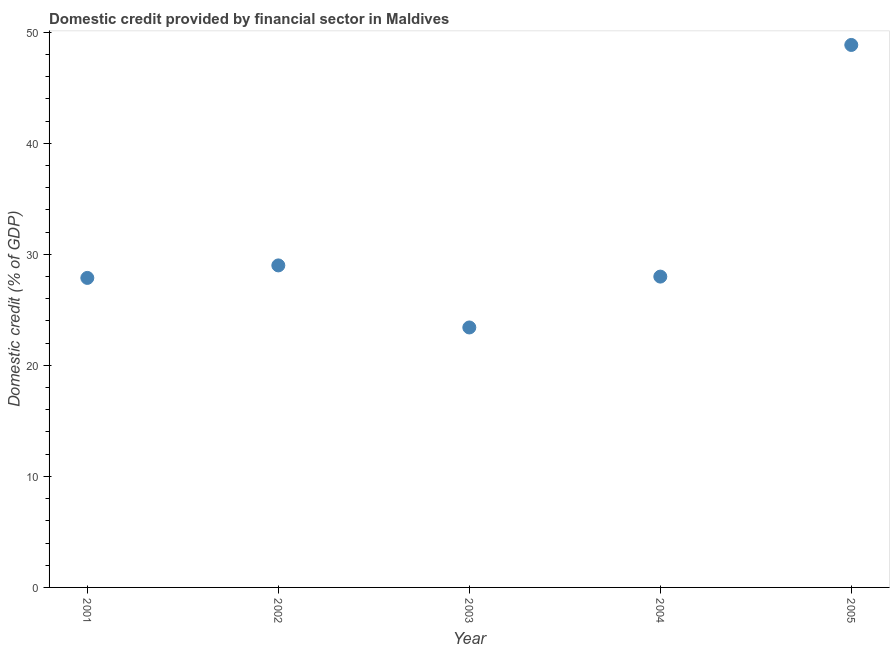What is the domestic credit provided by financial sector in 2005?
Provide a succinct answer. 48.85. Across all years, what is the maximum domestic credit provided by financial sector?
Provide a short and direct response. 48.85. Across all years, what is the minimum domestic credit provided by financial sector?
Your answer should be compact. 23.41. In which year was the domestic credit provided by financial sector maximum?
Your response must be concise. 2005. What is the sum of the domestic credit provided by financial sector?
Keep it short and to the point. 157.11. What is the difference between the domestic credit provided by financial sector in 2002 and 2003?
Make the answer very short. 5.59. What is the average domestic credit provided by financial sector per year?
Offer a very short reply. 31.42. What is the median domestic credit provided by financial sector?
Provide a succinct answer. 27.99. Do a majority of the years between 2003 and 2005 (inclusive) have domestic credit provided by financial sector greater than 28 %?
Your answer should be compact. No. What is the ratio of the domestic credit provided by financial sector in 2001 to that in 2005?
Provide a short and direct response. 0.57. Is the domestic credit provided by financial sector in 2002 less than that in 2005?
Give a very brief answer. Yes. What is the difference between the highest and the second highest domestic credit provided by financial sector?
Give a very brief answer. 19.85. What is the difference between the highest and the lowest domestic credit provided by financial sector?
Provide a short and direct response. 25.44. In how many years, is the domestic credit provided by financial sector greater than the average domestic credit provided by financial sector taken over all years?
Provide a short and direct response. 1. How many dotlines are there?
Make the answer very short. 1. What is the difference between two consecutive major ticks on the Y-axis?
Your answer should be very brief. 10. Are the values on the major ticks of Y-axis written in scientific E-notation?
Give a very brief answer. No. Does the graph contain grids?
Your answer should be compact. No. What is the title of the graph?
Your response must be concise. Domestic credit provided by financial sector in Maldives. What is the label or title of the X-axis?
Provide a short and direct response. Year. What is the label or title of the Y-axis?
Keep it short and to the point. Domestic credit (% of GDP). What is the Domestic credit (% of GDP) in 2001?
Provide a succinct answer. 27.87. What is the Domestic credit (% of GDP) in 2002?
Offer a very short reply. 29. What is the Domestic credit (% of GDP) in 2003?
Your answer should be compact. 23.41. What is the Domestic credit (% of GDP) in 2004?
Keep it short and to the point. 27.99. What is the Domestic credit (% of GDP) in 2005?
Provide a succinct answer. 48.85. What is the difference between the Domestic credit (% of GDP) in 2001 and 2002?
Your response must be concise. -1.13. What is the difference between the Domestic credit (% of GDP) in 2001 and 2003?
Provide a short and direct response. 4.46. What is the difference between the Domestic credit (% of GDP) in 2001 and 2004?
Ensure brevity in your answer.  -0.12. What is the difference between the Domestic credit (% of GDP) in 2001 and 2005?
Your response must be concise. -20.98. What is the difference between the Domestic credit (% of GDP) in 2002 and 2003?
Your answer should be very brief. 5.59. What is the difference between the Domestic credit (% of GDP) in 2002 and 2005?
Your answer should be compact. -19.85. What is the difference between the Domestic credit (% of GDP) in 2003 and 2004?
Keep it short and to the point. -4.58. What is the difference between the Domestic credit (% of GDP) in 2003 and 2005?
Offer a very short reply. -25.44. What is the difference between the Domestic credit (% of GDP) in 2004 and 2005?
Provide a succinct answer. -20.86. What is the ratio of the Domestic credit (% of GDP) in 2001 to that in 2002?
Your response must be concise. 0.96. What is the ratio of the Domestic credit (% of GDP) in 2001 to that in 2003?
Offer a very short reply. 1.19. What is the ratio of the Domestic credit (% of GDP) in 2001 to that in 2004?
Give a very brief answer. 1. What is the ratio of the Domestic credit (% of GDP) in 2001 to that in 2005?
Offer a very short reply. 0.57. What is the ratio of the Domestic credit (% of GDP) in 2002 to that in 2003?
Ensure brevity in your answer.  1.24. What is the ratio of the Domestic credit (% of GDP) in 2002 to that in 2004?
Give a very brief answer. 1.04. What is the ratio of the Domestic credit (% of GDP) in 2002 to that in 2005?
Your response must be concise. 0.59. What is the ratio of the Domestic credit (% of GDP) in 2003 to that in 2004?
Ensure brevity in your answer.  0.84. What is the ratio of the Domestic credit (% of GDP) in 2003 to that in 2005?
Provide a short and direct response. 0.48. What is the ratio of the Domestic credit (% of GDP) in 2004 to that in 2005?
Your answer should be very brief. 0.57. 